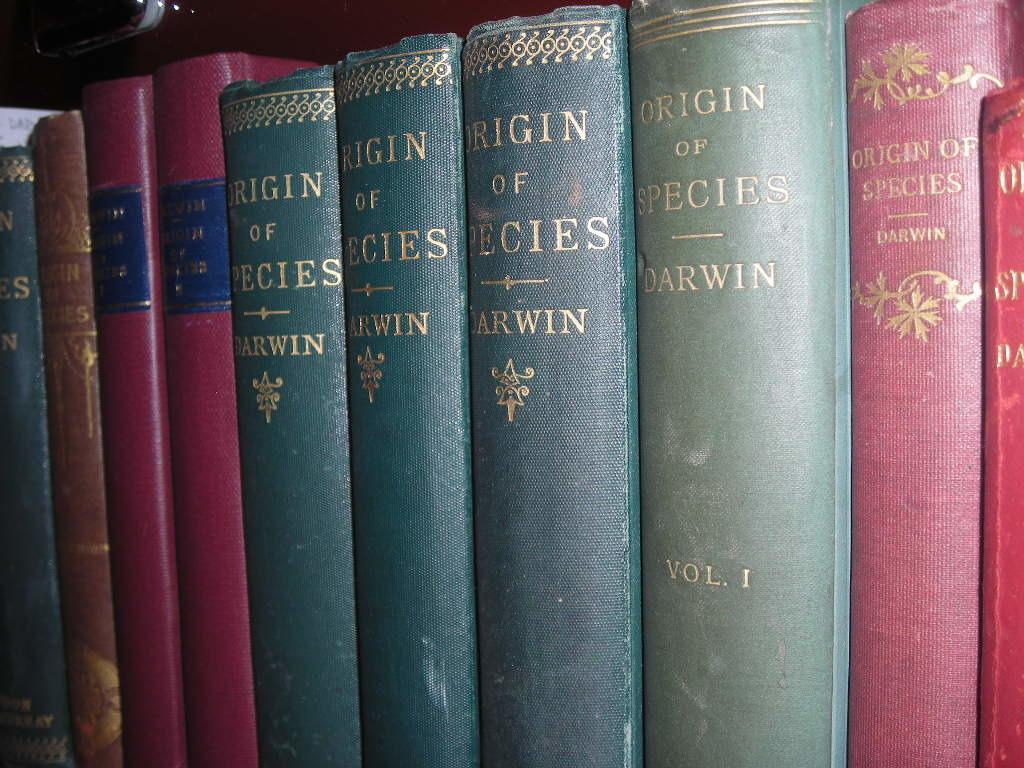<image>
Present a compact description of the photo's key features. A row of old Origin of Species books by Darwin. 